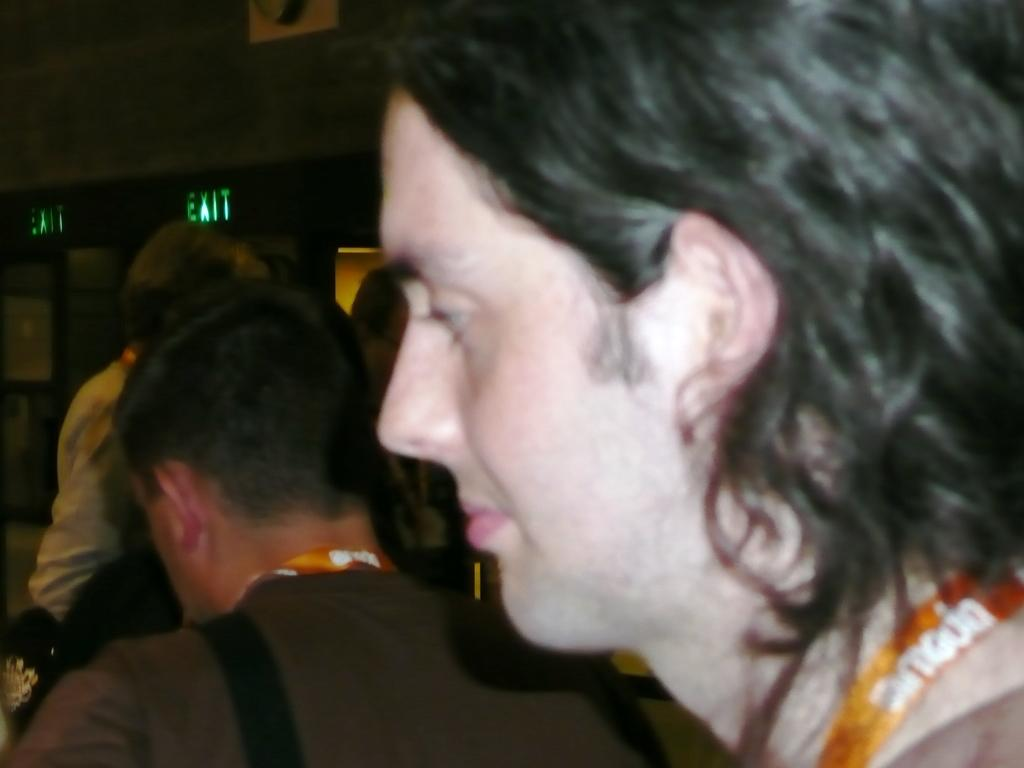How many people are in the image? There are people in the image. Can you describe the clothing of one of the individuals? One man is wearing a tag and a shirt. What direction is the man looking in? The man is looking to the left side. What can be seen in the background of the image? There is a wall in the background of the image. What type of quill is the man using to write on the wall in the image? There is no quill or writing on the wall visible in the image. What health precautions are being taken by the people in the image? The provided facts do not mention any health precautions being taken by the people in the image. 